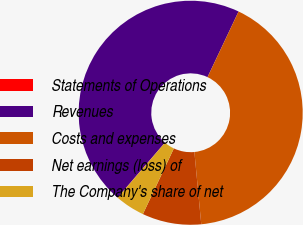Convert chart to OTSL. <chart><loc_0><loc_0><loc_500><loc_500><pie_chart><fcel>Statements of Operations<fcel>Revenues<fcel>Costs and expenses<fcel>Net earnings (loss) of<fcel>The Company's share of net<nl><fcel>0.03%<fcel>45.71%<fcel>41.46%<fcel>8.52%<fcel>4.28%<nl></chart> 